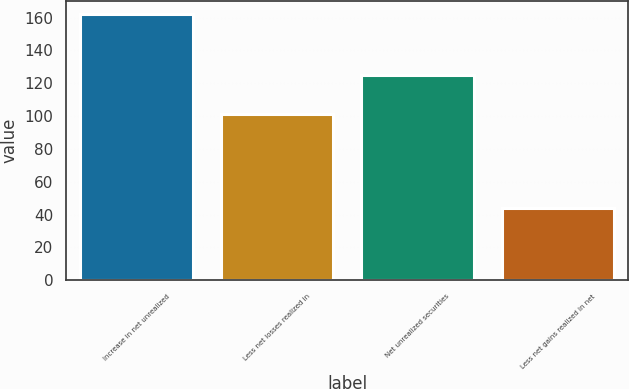<chart> <loc_0><loc_0><loc_500><loc_500><bar_chart><fcel>Increase in net unrealized<fcel>Less net losses realized in<fcel>Net unrealized securities<fcel>Less net gains realized in net<nl><fcel>162.2<fcel>101<fcel>125<fcel>44<nl></chart> 